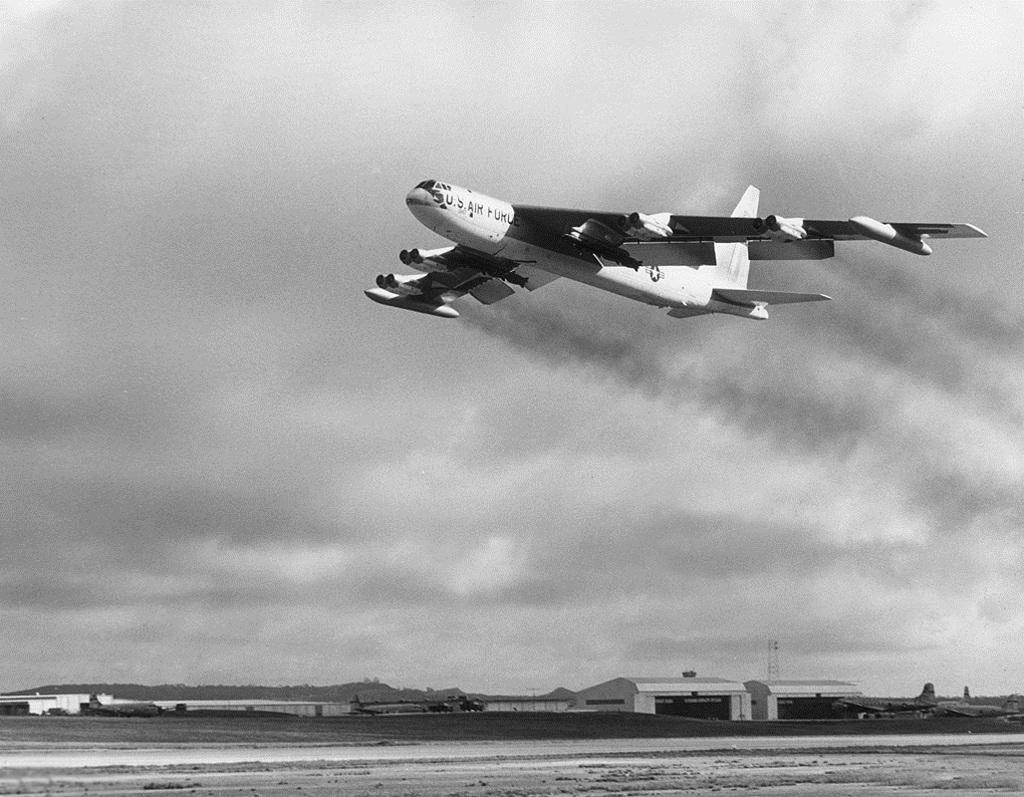<image>
Create a compact narrative representing the image presented. An airplane with the words U.S. Air Force written on the front 